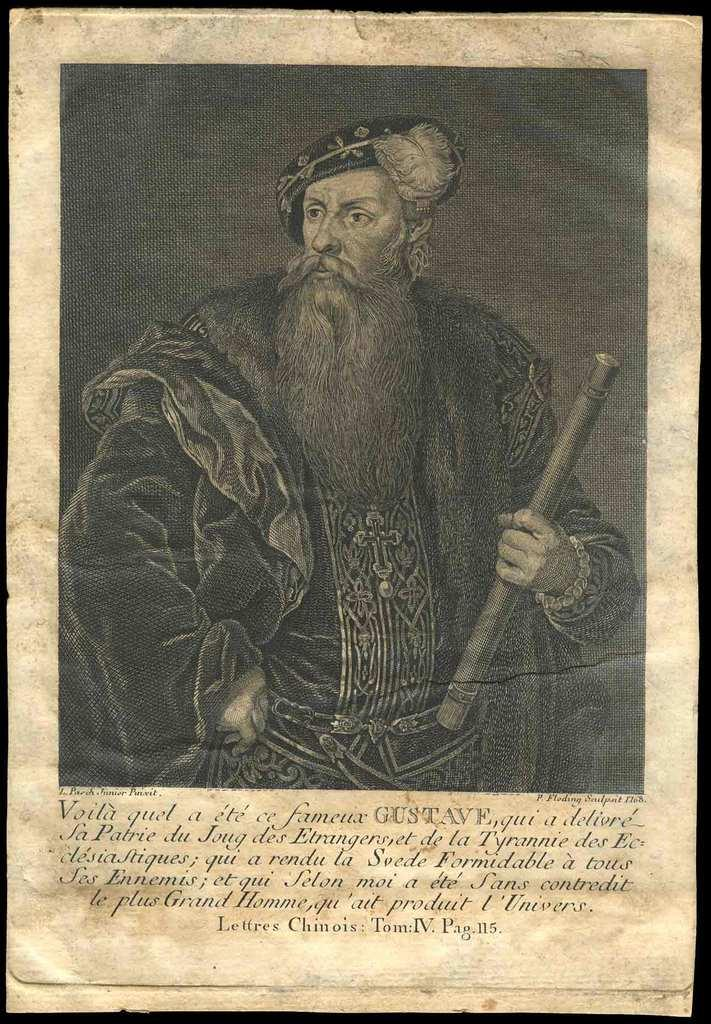What is the main subject of the image? The main subject of the image is a paper. What is depicted on the paper? The paper features a man wearing ancient clothes. What is the man holding in the image? The man is holding an object. Is there any text on the paper? Yes, there is text at the bottom of the paper. How does the group of people in the image react to the man's thoughts? There is no group of people present in the image, and therefore no reaction to the man's thoughts can be observed. 